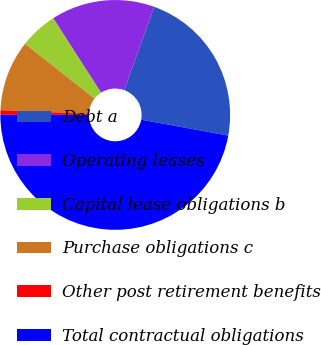Convert chart to OTSL. <chart><loc_0><loc_0><loc_500><loc_500><pie_chart><fcel>Debt a<fcel>Operating leases<fcel>Capital lease obligations b<fcel>Purchase obligations c<fcel>Other post retirement benefits<fcel>Total contractual obligations<nl><fcel>22.38%<fcel>14.59%<fcel>5.3%<fcel>9.95%<fcel>0.65%<fcel>47.13%<nl></chart> 